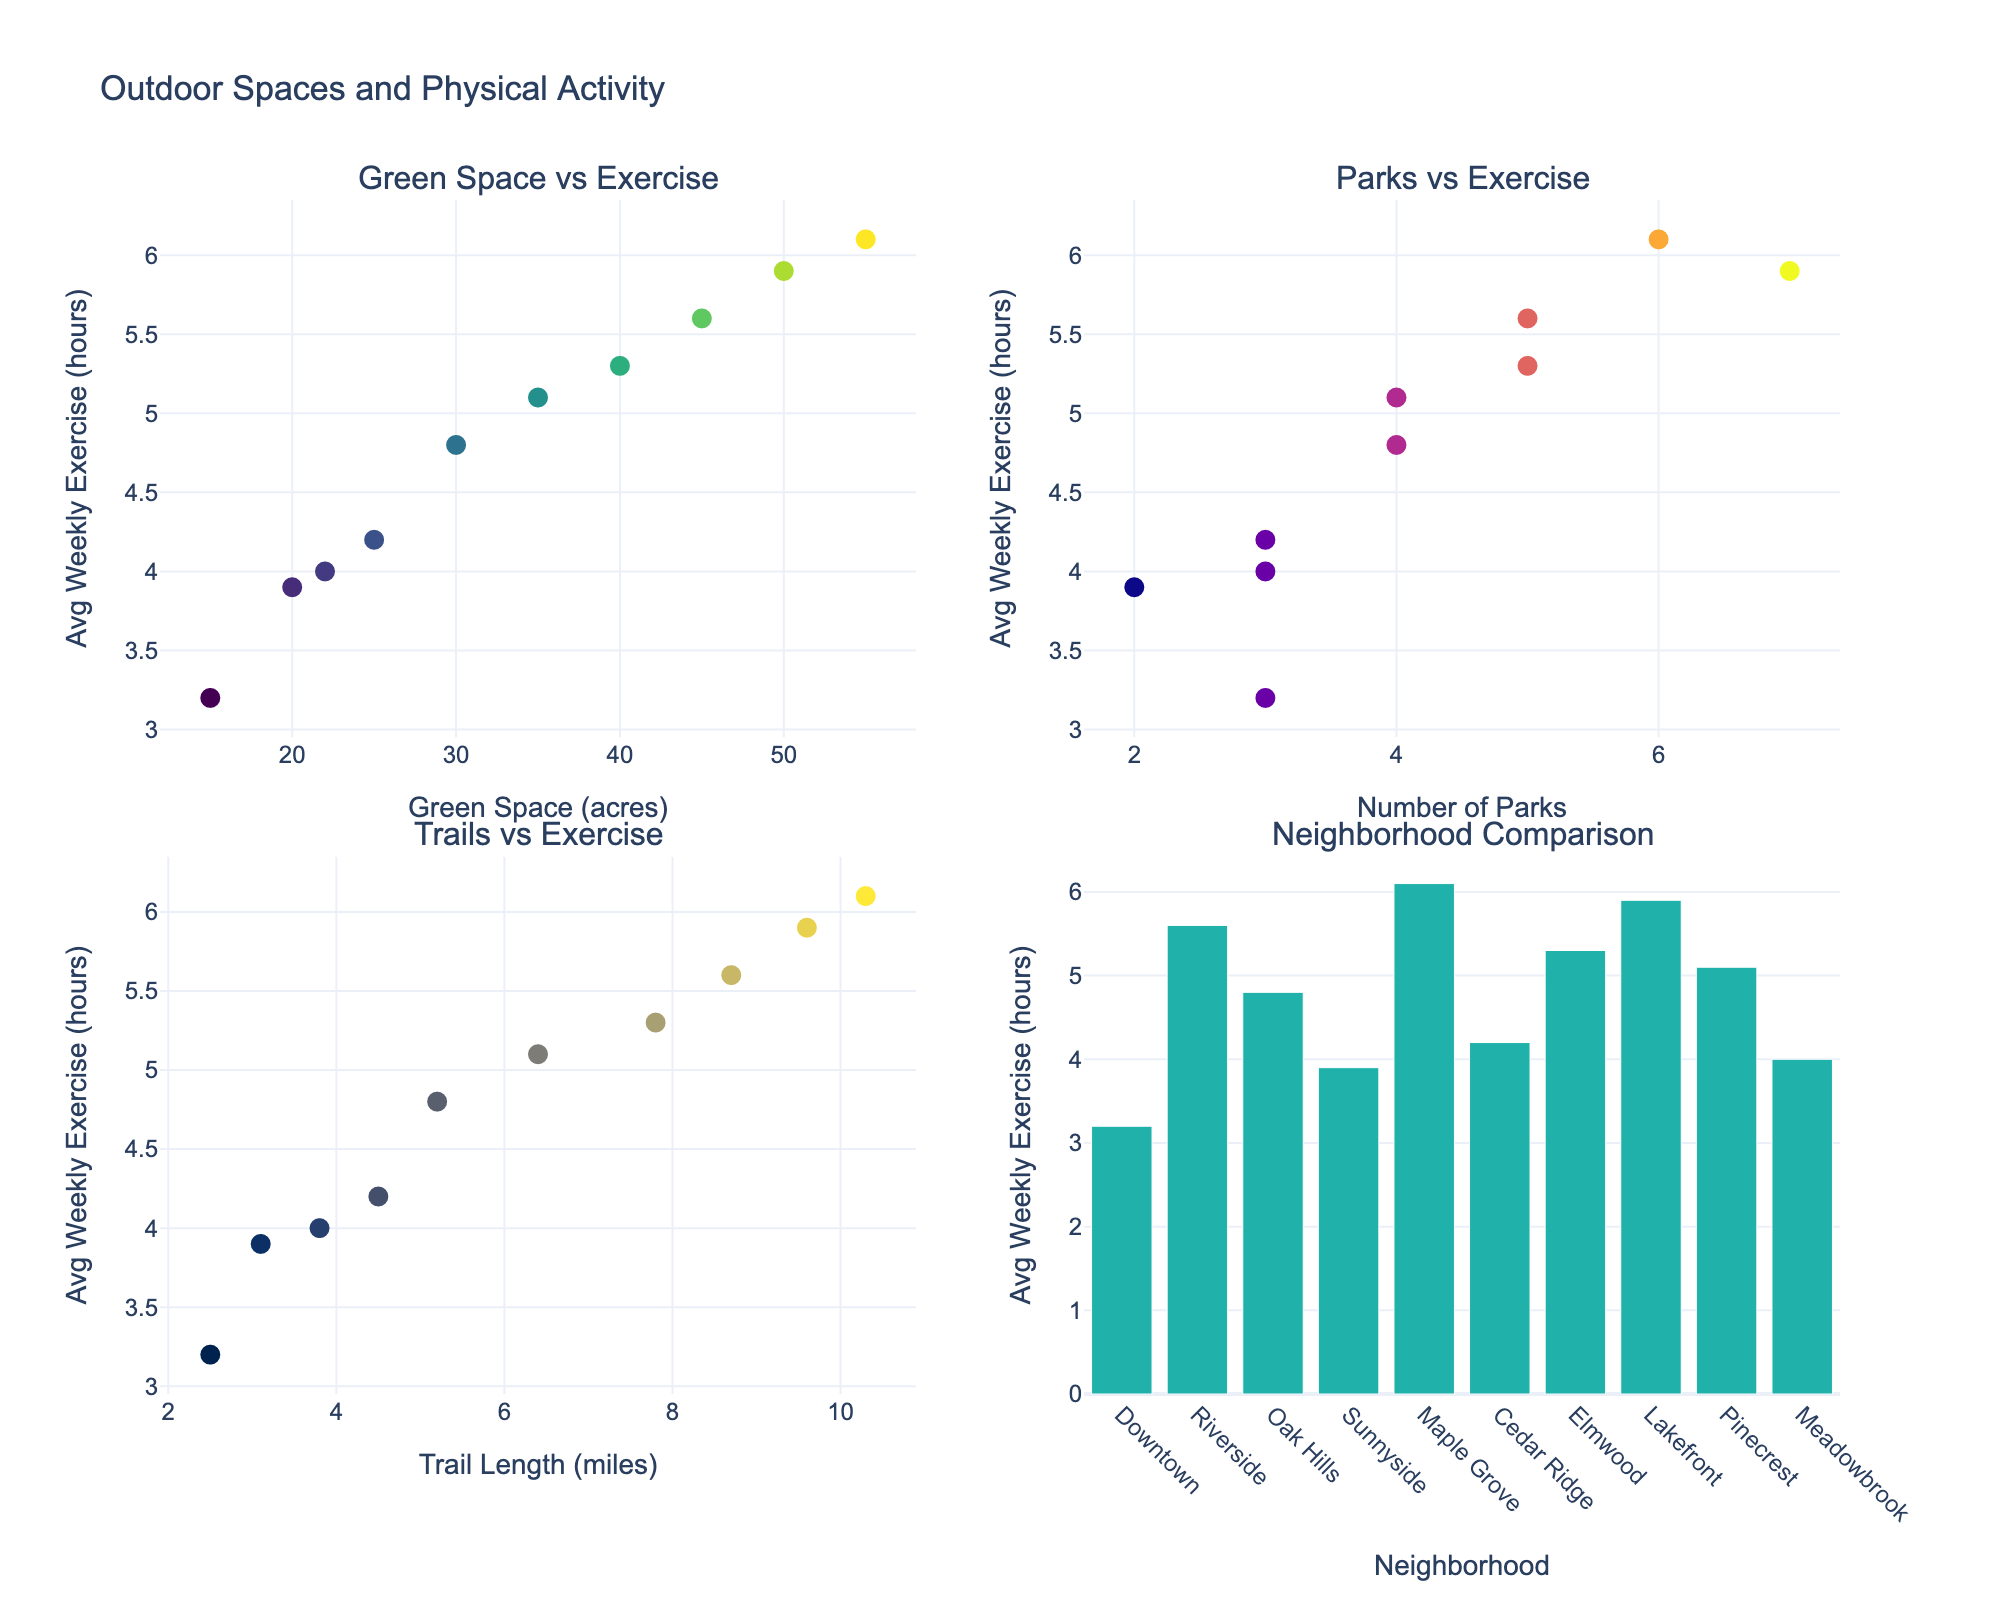Which neighborhood has the largest green space? The bar chart shows the green space in each neighborhood. By comparing the lengths of the bars, Maple Grove has the longest bar representing 55 acres.
Answer: Maple Grove How many neighborhoods have more than 4 average weekly exercise hours? The bar chart plotting average weekly exercise hours makes it easy to see bars exceeding the 4-hour mark. Identifying them: Riverside, Oak Hills, Maple Grove, Elmwood, Lakefront, Pinecrest.
Answer: 6 What's the relationship between the number of parks and average weekly exercise hours? The scatter plot "Parks vs Exercise" shows a positive trend where neighborhoods with more parks tend to have higher average weekly exercise hours. Generally, an increase in parks correlates with an increase in exercise hours.
Answer: Positive correlation Do longer trails in a neighborhood result in higher average weekly exercise hours? The scatter plot "Trails vs Exercise" displays data points denoting trail lengths and weekly exercise hours. There is a visible positive correlation indicating longer trails are generally associated with higher exercise hours.
Answer: Yes Which neighborhood has the lowest average weekly exercise hours? Refer to the bar chart which shows a comparison across neighborhoods. The shortest bar represents Downtown.
Answer: Downtown In neighborhoods with 3 parks, what is the range of average weekly exercise hours? Identifying the neighborhoods with 3 parks from the scatter plot "Parks vs Exercise" (Downtown, Cedar Ridge, Meadowbrook), the exercise hours are 3.2, 4.2, and 4.0 respectively. The range is calculated as 4.2 - 3.2.
Answer: 1 hour Which neighborhood has the highest average weekly exercise hours and how many parks does it have? From the bar chart, Maple Grove has the highest weekly exercise hours at 6.1 hours. By checking the scatter plot "Parks vs Exercise", Maple Grove has 6 parks.
Answer: Maple Grove, 6 parks How does exercise time vary between neighborhoods with vast green spaces (e.g., 45 acres and above) and those with less? By examining the scatter plot "Green Space vs Exercise" and comparing data points, neighborhoods with vast green spaces (Riverside, Maple Grove, Lakefront) have 5.6, 6.1, and 5.9 hours respectively, showing higher values than those with less green space.
Answer: More green space tends to result in higher exercise time 